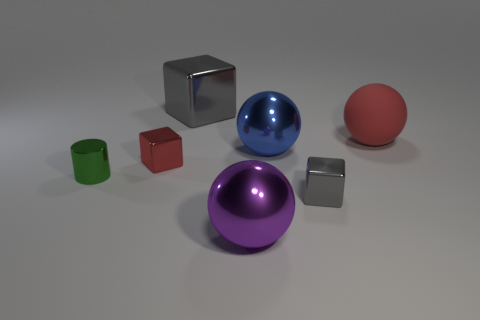Is the material of the small cylinder the same as the gray thing that is in front of the blue sphere?
Offer a very short reply. Yes. What is the color of the cube that is behind the big thing that is to the right of the tiny shiny thing that is on the right side of the blue object?
Your answer should be compact. Gray. There is a cylinder; is it the same color as the cube behind the red matte ball?
Your answer should be very brief. No. The rubber sphere has what color?
Your answer should be compact. Red. There is a red object that is to the right of the tiny cube that is right of the shiny block behind the large blue metallic thing; what is its shape?
Keep it short and to the point. Sphere. How many other things are the same color as the metallic cylinder?
Offer a very short reply. 0. Are there more small blocks that are on the left side of the big blue metallic sphere than purple shiny objects behind the big red matte sphere?
Provide a short and direct response. Yes. There is a large purple metallic object; are there any large spheres to the right of it?
Offer a very short reply. Yes. There is a big object that is behind the big blue ball and in front of the large gray thing; what material is it made of?
Provide a succinct answer. Rubber. What is the color of the other shiny object that is the same shape as the big blue metallic object?
Offer a terse response. Purple. 